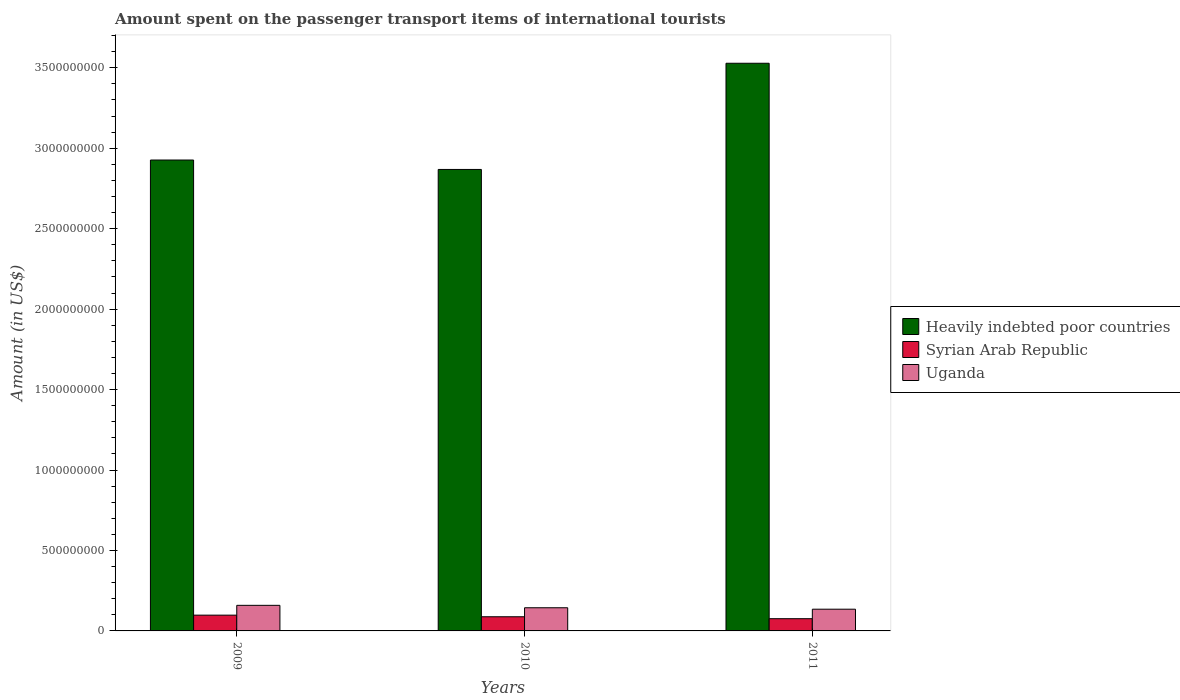How many different coloured bars are there?
Your answer should be compact. 3. How many bars are there on the 1st tick from the left?
Your answer should be compact. 3. How many bars are there on the 1st tick from the right?
Your response must be concise. 3. What is the label of the 3rd group of bars from the left?
Offer a very short reply. 2011. In how many cases, is the number of bars for a given year not equal to the number of legend labels?
Your answer should be compact. 0. What is the amount spent on the passenger transport items of international tourists in Syrian Arab Republic in 2010?
Provide a succinct answer. 8.80e+07. Across all years, what is the maximum amount spent on the passenger transport items of international tourists in Heavily indebted poor countries?
Make the answer very short. 3.53e+09. Across all years, what is the minimum amount spent on the passenger transport items of international tourists in Heavily indebted poor countries?
Make the answer very short. 2.87e+09. In which year was the amount spent on the passenger transport items of international tourists in Heavily indebted poor countries minimum?
Ensure brevity in your answer.  2010. What is the total amount spent on the passenger transport items of international tourists in Uganda in the graph?
Your answer should be very brief. 4.38e+08. What is the difference between the amount spent on the passenger transport items of international tourists in Heavily indebted poor countries in 2010 and that in 2011?
Your response must be concise. -6.60e+08. What is the difference between the amount spent on the passenger transport items of international tourists in Syrian Arab Republic in 2011 and the amount spent on the passenger transport items of international tourists in Heavily indebted poor countries in 2010?
Your answer should be very brief. -2.79e+09. What is the average amount spent on the passenger transport items of international tourists in Syrian Arab Republic per year?
Your answer should be compact. 8.73e+07. In the year 2009, what is the difference between the amount spent on the passenger transport items of international tourists in Heavily indebted poor countries and amount spent on the passenger transport items of international tourists in Uganda?
Keep it short and to the point. 2.77e+09. In how many years, is the amount spent on the passenger transport items of international tourists in Syrian Arab Republic greater than 1800000000 US$?
Make the answer very short. 0. What is the ratio of the amount spent on the passenger transport items of international tourists in Heavily indebted poor countries in 2010 to that in 2011?
Offer a very short reply. 0.81. Is the amount spent on the passenger transport items of international tourists in Heavily indebted poor countries in 2010 less than that in 2011?
Provide a short and direct response. Yes. What is the difference between the highest and the second highest amount spent on the passenger transport items of international tourists in Uganda?
Offer a terse response. 1.50e+07. What is the difference between the highest and the lowest amount spent on the passenger transport items of international tourists in Uganda?
Make the answer very short. 2.40e+07. Is the sum of the amount spent on the passenger transport items of international tourists in Heavily indebted poor countries in 2009 and 2011 greater than the maximum amount spent on the passenger transport items of international tourists in Syrian Arab Republic across all years?
Your answer should be very brief. Yes. What does the 2nd bar from the left in 2011 represents?
Make the answer very short. Syrian Arab Republic. What does the 3rd bar from the right in 2009 represents?
Provide a short and direct response. Heavily indebted poor countries. Is it the case that in every year, the sum of the amount spent on the passenger transport items of international tourists in Uganda and amount spent on the passenger transport items of international tourists in Syrian Arab Republic is greater than the amount spent on the passenger transport items of international tourists in Heavily indebted poor countries?
Offer a terse response. No. How many bars are there?
Keep it short and to the point. 9. Does the graph contain any zero values?
Give a very brief answer. No. Does the graph contain grids?
Make the answer very short. No. Where does the legend appear in the graph?
Provide a succinct answer. Center right. How many legend labels are there?
Make the answer very short. 3. What is the title of the graph?
Keep it short and to the point. Amount spent on the passenger transport items of international tourists. Does "Rwanda" appear as one of the legend labels in the graph?
Provide a short and direct response. No. What is the label or title of the X-axis?
Make the answer very short. Years. What is the Amount (in US$) in Heavily indebted poor countries in 2009?
Ensure brevity in your answer.  2.93e+09. What is the Amount (in US$) in Syrian Arab Republic in 2009?
Your response must be concise. 9.80e+07. What is the Amount (in US$) of Uganda in 2009?
Your response must be concise. 1.59e+08. What is the Amount (in US$) in Heavily indebted poor countries in 2010?
Provide a short and direct response. 2.87e+09. What is the Amount (in US$) of Syrian Arab Republic in 2010?
Provide a short and direct response. 8.80e+07. What is the Amount (in US$) in Uganda in 2010?
Provide a succinct answer. 1.44e+08. What is the Amount (in US$) of Heavily indebted poor countries in 2011?
Keep it short and to the point. 3.53e+09. What is the Amount (in US$) of Syrian Arab Republic in 2011?
Offer a terse response. 7.60e+07. What is the Amount (in US$) in Uganda in 2011?
Give a very brief answer. 1.35e+08. Across all years, what is the maximum Amount (in US$) in Heavily indebted poor countries?
Provide a succinct answer. 3.53e+09. Across all years, what is the maximum Amount (in US$) of Syrian Arab Republic?
Ensure brevity in your answer.  9.80e+07. Across all years, what is the maximum Amount (in US$) in Uganda?
Provide a short and direct response. 1.59e+08. Across all years, what is the minimum Amount (in US$) in Heavily indebted poor countries?
Provide a succinct answer. 2.87e+09. Across all years, what is the minimum Amount (in US$) of Syrian Arab Republic?
Your answer should be compact. 7.60e+07. Across all years, what is the minimum Amount (in US$) of Uganda?
Your answer should be compact. 1.35e+08. What is the total Amount (in US$) of Heavily indebted poor countries in the graph?
Provide a short and direct response. 9.32e+09. What is the total Amount (in US$) in Syrian Arab Republic in the graph?
Your answer should be compact. 2.62e+08. What is the total Amount (in US$) of Uganda in the graph?
Give a very brief answer. 4.38e+08. What is the difference between the Amount (in US$) of Heavily indebted poor countries in 2009 and that in 2010?
Provide a short and direct response. 5.85e+07. What is the difference between the Amount (in US$) in Uganda in 2009 and that in 2010?
Make the answer very short. 1.50e+07. What is the difference between the Amount (in US$) in Heavily indebted poor countries in 2009 and that in 2011?
Your answer should be very brief. -6.01e+08. What is the difference between the Amount (in US$) of Syrian Arab Republic in 2009 and that in 2011?
Your response must be concise. 2.20e+07. What is the difference between the Amount (in US$) of Uganda in 2009 and that in 2011?
Provide a succinct answer. 2.40e+07. What is the difference between the Amount (in US$) of Heavily indebted poor countries in 2010 and that in 2011?
Ensure brevity in your answer.  -6.60e+08. What is the difference between the Amount (in US$) of Uganda in 2010 and that in 2011?
Your response must be concise. 9.00e+06. What is the difference between the Amount (in US$) in Heavily indebted poor countries in 2009 and the Amount (in US$) in Syrian Arab Republic in 2010?
Give a very brief answer. 2.84e+09. What is the difference between the Amount (in US$) in Heavily indebted poor countries in 2009 and the Amount (in US$) in Uganda in 2010?
Offer a terse response. 2.78e+09. What is the difference between the Amount (in US$) in Syrian Arab Republic in 2009 and the Amount (in US$) in Uganda in 2010?
Your response must be concise. -4.60e+07. What is the difference between the Amount (in US$) in Heavily indebted poor countries in 2009 and the Amount (in US$) in Syrian Arab Republic in 2011?
Provide a succinct answer. 2.85e+09. What is the difference between the Amount (in US$) of Heavily indebted poor countries in 2009 and the Amount (in US$) of Uganda in 2011?
Provide a succinct answer. 2.79e+09. What is the difference between the Amount (in US$) of Syrian Arab Republic in 2009 and the Amount (in US$) of Uganda in 2011?
Provide a succinct answer. -3.70e+07. What is the difference between the Amount (in US$) in Heavily indebted poor countries in 2010 and the Amount (in US$) in Syrian Arab Republic in 2011?
Give a very brief answer. 2.79e+09. What is the difference between the Amount (in US$) of Heavily indebted poor countries in 2010 and the Amount (in US$) of Uganda in 2011?
Keep it short and to the point. 2.73e+09. What is the difference between the Amount (in US$) of Syrian Arab Republic in 2010 and the Amount (in US$) of Uganda in 2011?
Offer a very short reply. -4.70e+07. What is the average Amount (in US$) of Heavily indebted poor countries per year?
Provide a short and direct response. 3.11e+09. What is the average Amount (in US$) of Syrian Arab Republic per year?
Give a very brief answer. 8.73e+07. What is the average Amount (in US$) of Uganda per year?
Ensure brevity in your answer.  1.46e+08. In the year 2009, what is the difference between the Amount (in US$) of Heavily indebted poor countries and Amount (in US$) of Syrian Arab Republic?
Make the answer very short. 2.83e+09. In the year 2009, what is the difference between the Amount (in US$) in Heavily indebted poor countries and Amount (in US$) in Uganda?
Provide a short and direct response. 2.77e+09. In the year 2009, what is the difference between the Amount (in US$) in Syrian Arab Republic and Amount (in US$) in Uganda?
Provide a succinct answer. -6.10e+07. In the year 2010, what is the difference between the Amount (in US$) in Heavily indebted poor countries and Amount (in US$) in Syrian Arab Republic?
Provide a short and direct response. 2.78e+09. In the year 2010, what is the difference between the Amount (in US$) of Heavily indebted poor countries and Amount (in US$) of Uganda?
Ensure brevity in your answer.  2.72e+09. In the year 2010, what is the difference between the Amount (in US$) in Syrian Arab Republic and Amount (in US$) in Uganda?
Your answer should be compact. -5.60e+07. In the year 2011, what is the difference between the Amount (in US$) of Heavily indebted poor countries and Amount (in US$) of Syrian Arab Republic?
Give a very brief answer. 3.45e+09. In the year 2011, what is the difference between the Amount (in US$) of Heavily indebted poor countries and Amount (in US$) of Uganda?
Keep it short and to the point. 3.39e+09. In the year 2011, what is the difference between the Amount (in US$) in Syrian Arab Republic and Amount (in US$) in Uganda?
Give a very brief answer. -5.90e+07. What is the ratio of the Amount (in US$) in Heavily indebted poor countries in 2009 to that in 2010?
Offer a very short reply. 1.02. What is the ratio of the Amount (in US$) in Syrian Arab Republic in 2009 to that in 2010?
Your answer should be very brief. 1.11. What is the ratio of the Amount (in US$) of Uganda in 2009 to that in 2010?
Give a very brief answer. 1.1. What is the ratio of the Amount (in US$) in Heavily indebted poor countries in 2009 to that in 2011?
Provide a succinct answer. 0.83. What is the ratio of the Amount (in US$) in Syrian Arab Republic in 2009 to that in 2011?
Ensure brevity in your answer.  1.29. What is the ratio of the Amount (in US$) of Uganda in 2009 to that in 2011?
Provide a short and direct response. 1.18. What is the ratio of the Amount (in US$) of Heavily indebted poor countries in 2010 to that in 2011?
Your answer should be compact. 0.81. What is the ratio of the Amount (in US$) of Syrian Arab Republic in 2010 to that in 2011?
Offer a very short reply. 1.16. What is the ratio of the Amount (in US$) in Uganda in 2010 to that in 2011?
Provide a short and direct response. 1.07. What is the difference between the highest and the second highest Amount (in US$) in Heavily indebted poor countries?
Offer a very short reply. 6.01e+08. What is the difference between the highest and the second highest Amount (in US$) in Syrian Arab Republic?
Provide a succinct answer. 1.00e+07. What is the difference between the highest and the second highest Amount (in US$) in Uganda?
Your response must be concise. 1.50e+07. What is the difference between the highest and the lowest Amount (in US$) of Heavily indebted poor countries?
Keep it short and to the point. 6.60e+08. What is the difference between the highest and the lowest Amount (in US$) of Syrian Arab Republic?
Your answer should be compact. 2.20e+07. What is the difference between the highest and the lowest Amount (in US$) in Uganda?
Offer a very short reply. 2.40e+07. 